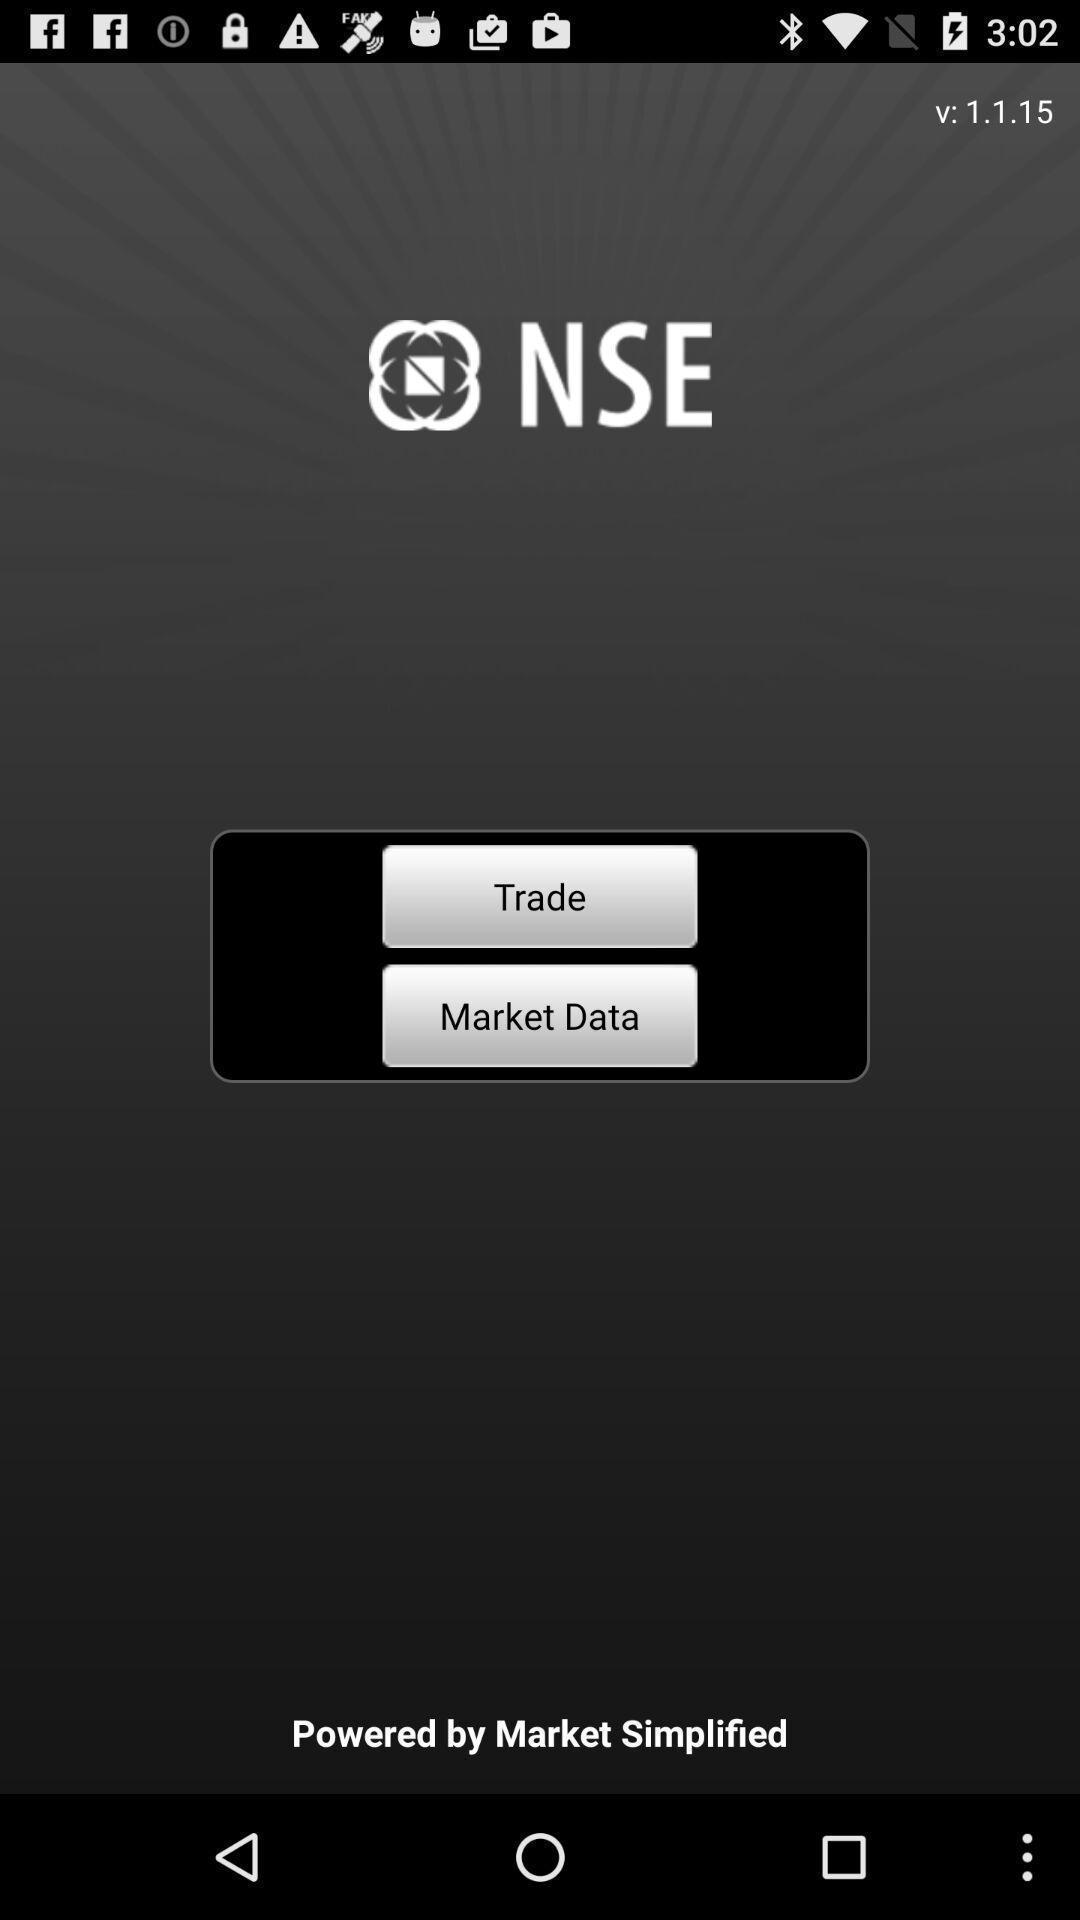What details can you identify in this image? Two options available in marketing app. 